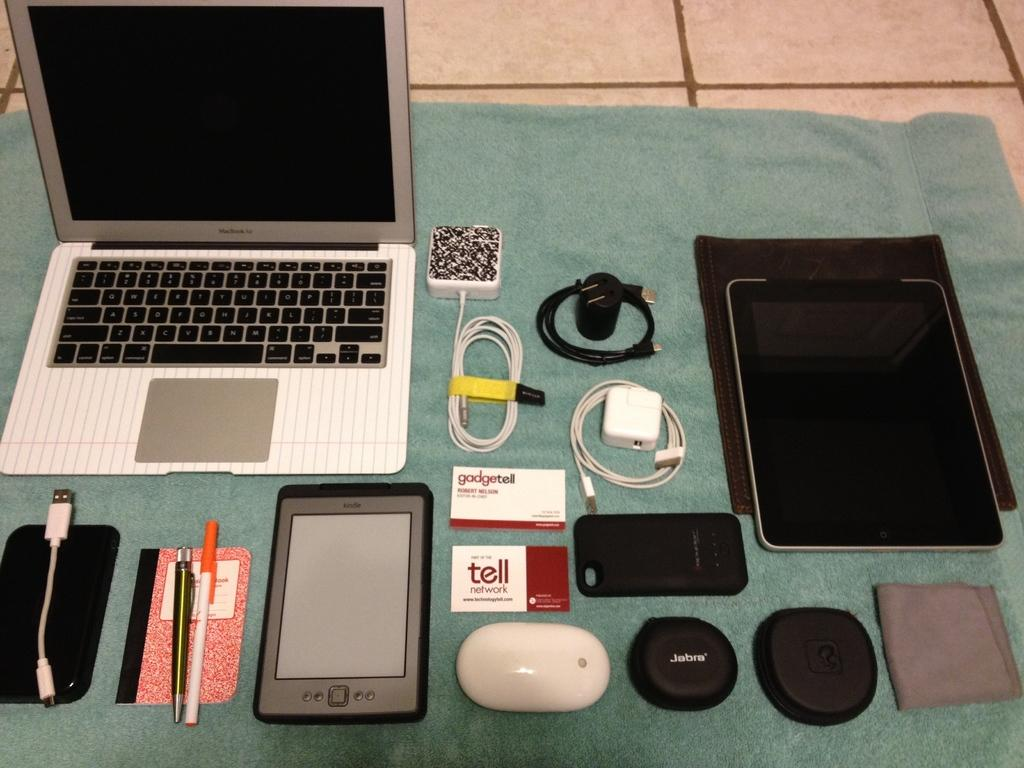<image>
Present a compact description of the photo's key features. An open Macbook is surrounded by peripherals and a Kindle. 